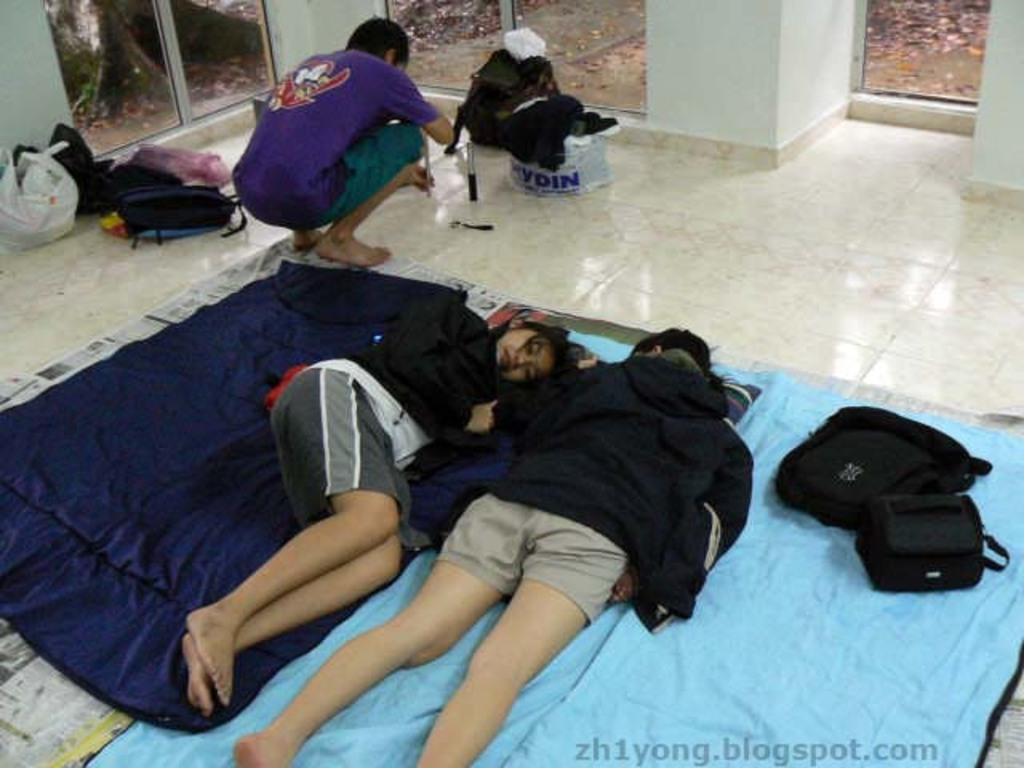<image>
Write a terse but informative summary of the picture. People are sleeping on the floor and the tag at the bottom reads, "Zh1yong.blogspot.com. 